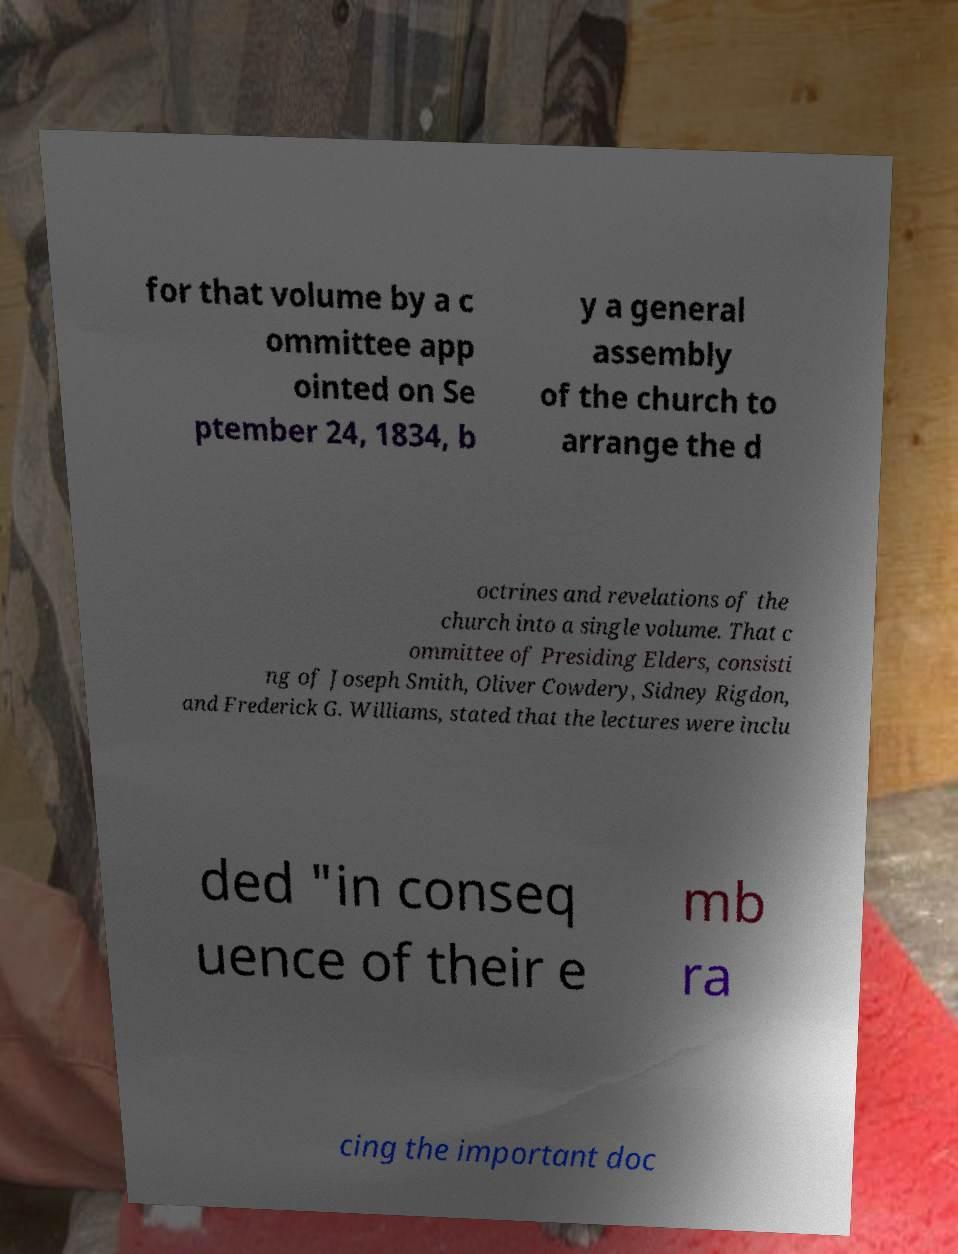Please read and relay the text visible in this image. What does it say? for that volume by a c ommittee app ointed on Se ptember 24, 1834, b y a general assembly of the church to arrange the d octrines and revelations of the church into a single volume. That c ommittee of Presiding Elders, consisti ng of Joseph Smith, Oliver Cowdery, Sidney Rigdon, and Frederick G. Williams, stated that the lectures were inclu ded "in conseq uence of their e mb ra cing the important doc 